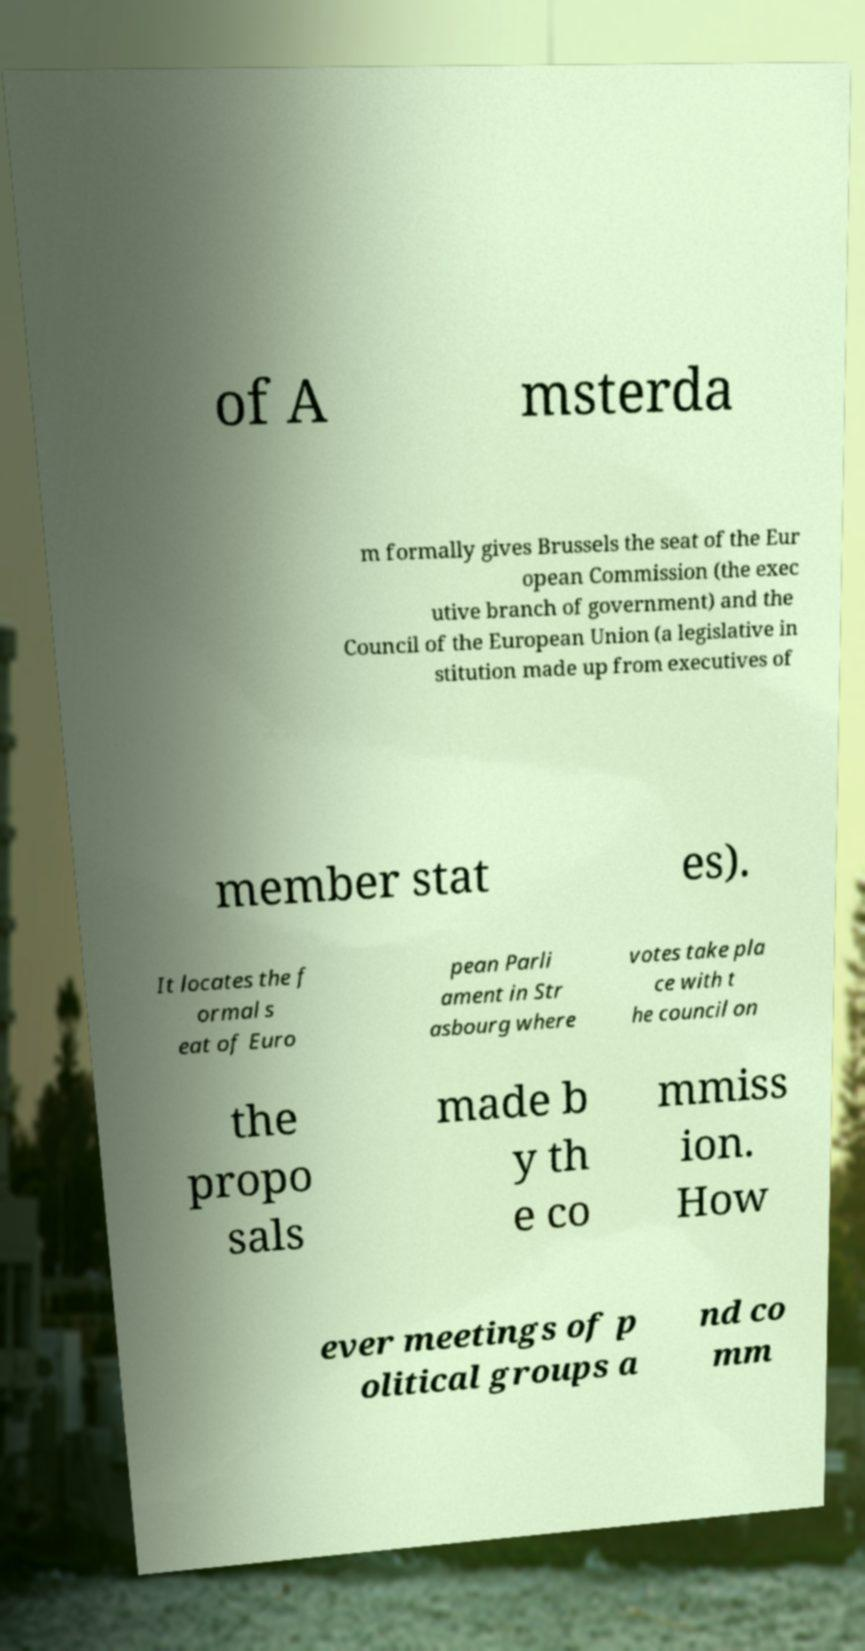Please read and relay the text visible in this image. What does it say? of A msterda m formally gives Brussels the seat of the Eur opean Commission (the exec utive branch of government) and the Council of the European Union (a legislative in stitution made up from executives of member stat es). It locates the f ormal s eat of Euro pean Parli ament in Str asbourg where votes take pla ce with t he council on the propo sals made b y th e co mmiss ion. How ever meetings of p olitical groups a nd co mm 